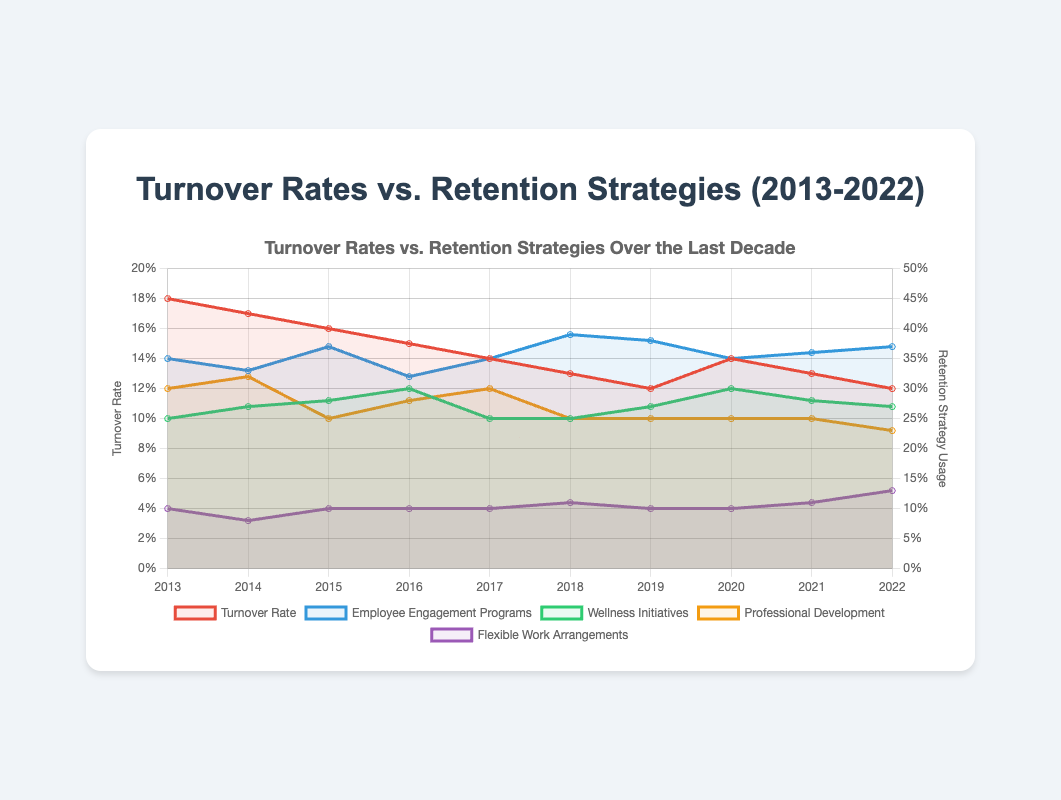What was the turnover rate in 2016? The turnover rate in 2016 can be seen on the chart, where the red line represents the turnover rate. In 2016, it is at 0.15 or 15%.
Answer: 15% Which year saw the highest usage of Wellness Initiatives and what was the turnover rate that year? By looking at the green line that represents Wellness Initiatives, we see it peaks in 2020. For the same year, the turnover rate (red line) is 0.14 or 14%.
Answer: 2020, 14% Which retention strategy had the largest increase in usage from 2018 to 2022? Evaluate the difference in the percentages for each retention strategy from 2018 to 2022. Employee Engagement Programs increased from 0.39 in 2018 to 0.37 in 2022, a decrease. Wellness Initiatives remained constant at about 0.27, Professional Development decreased from 0.25 to 0.23. Flexible Work Arrangements increased from 0.11 to 0.13. Therefore, Flexible Work Arrangements had the largest increase.
Answer: Flexible Work Arrangements What is the average turnover rate over the entire period (2013-2022)? Sum up all the turnover rates from 2013 to 2022, then divide by the number of years. (0.18 + 0.17 + 0.16 + 0.15 + 0.14 + 0.13 + 0.12 + 0.14 + 0.13 + 0.12) = 1.44. Divide by 10 years: 1.44 / 10 = 0.144 or 14.4%.
Answer: 14.4% Between which two consecutive years did the turnover rate see the largest decrease? Look at the red line and find the steepest downward slope between two consecutive years. The largest decrease happened between 2013 and 2014 where the turnover rate went from 0.18 to 0.17, a 0.01 or 1% drop. However, between 2019 and 2020, turnover increased, hence between 2018 and 2019 the turnover decreased by 0.13 - 0.12 = 0.01.
Answer: 2013-2014 Was Professional Development usage higher or lower in 2015 compared to 2014? Compare the yellow lines representing Professional Development in 2014 and 2015. In 2014, the usage is 0.32 and in 2015, it's 0.25. Therefore, it decreased.
Answer: Lower How do Employee Engagement Programs impact turnover rates over the years? By examining the blue line (Employee Engagement Programs) relative to the red line (Turnover Rate), we see that as the Engagement Programs increase or stay relatively high, the turnover rate tends to decrease, implying an inverse relationship.
Answer: Inversely related By what percentage did Flexible Work Arrangements increase from 2014 to 2022? The usage of Flexible Work Arrangements in 2014 was 0.08 and in 2022, it was 0.13. The percentage increase is calculated as ((0.13 - 0.08)/0.08) * 100 = 62.5%.
Answer: 62.5% 